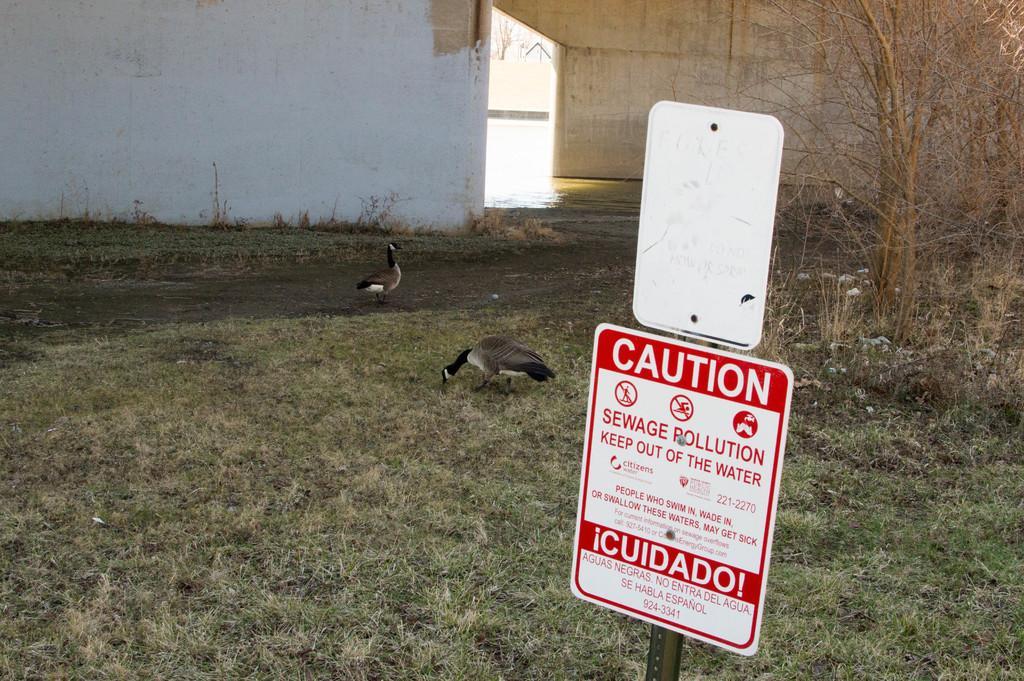Please provide a concise description of this image. In the foreground of the picture there are boards and grass. On the right there are trees and plants. In the center of the picture there are ducks, grass and path. In the background we can see wall. 